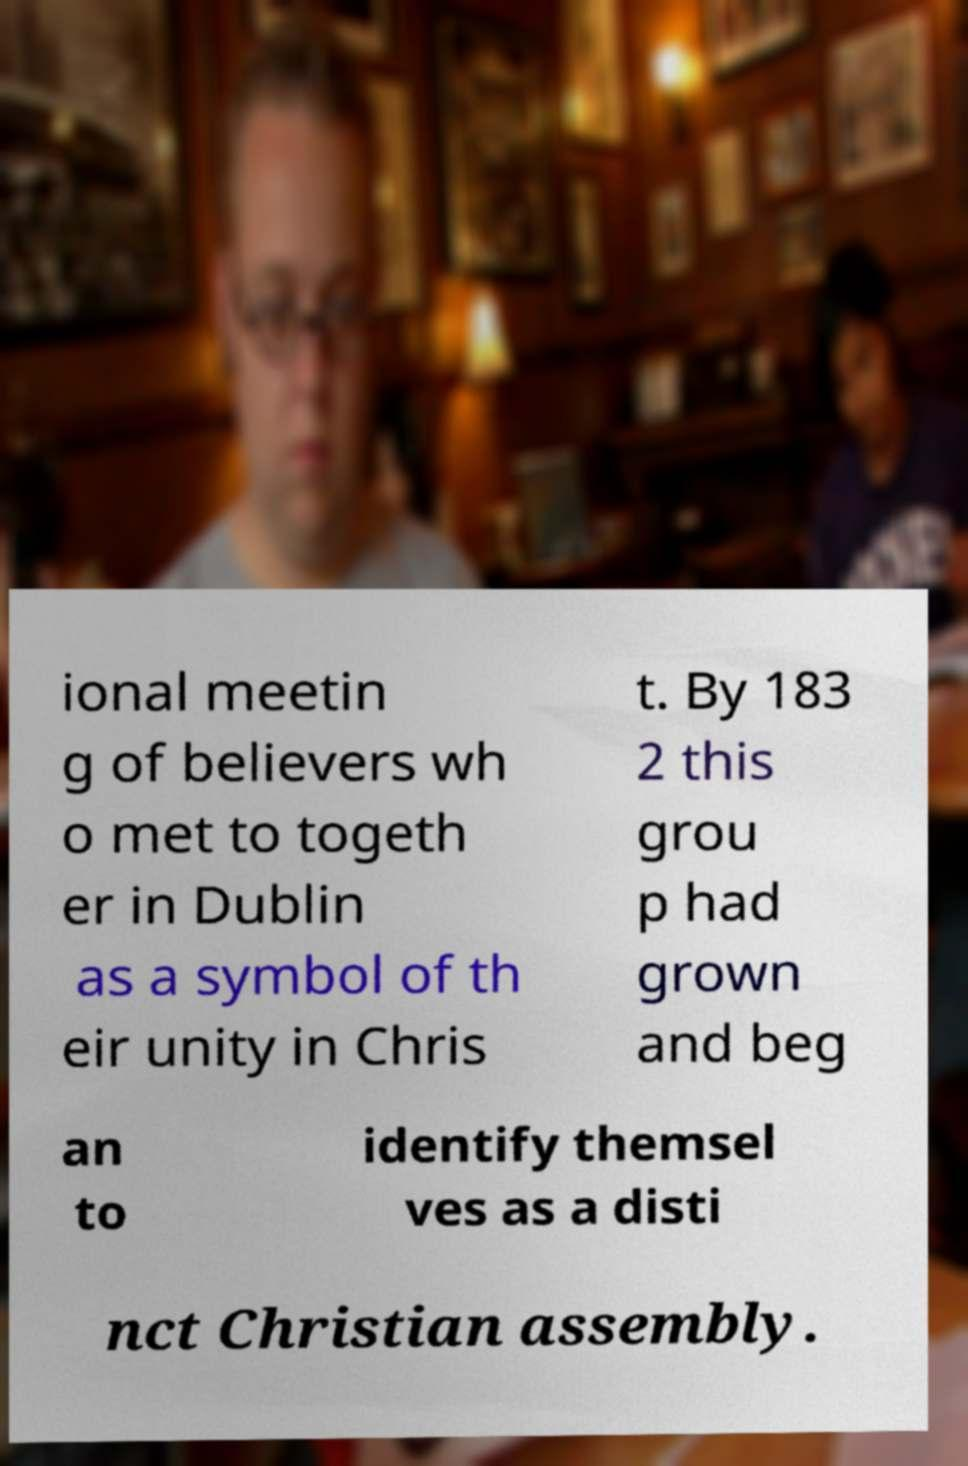Please identify and transcribe the text found in this image. ional meetin g of believers wh o met to togeth er in Dublin as a symbol of th eir unity in Chris t. By 183 2 this grou p had grown and beg an to identify themsel ves as a disti nct Christian assembly. 